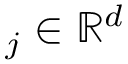<formula> <loc_0><loc_0><loc_500><loc_500>_ { j } \in \mathbb { R } ^ { d }</formula> 